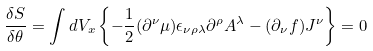Convert formula to latex. <formula><loc_0><loc_0><loc_500><loc_500>\frac { \delta S } { \delta \theta } = \int d V _ { x } \left \{ - \frac { 1 } { 2 } ( \partial ^ { \nu } \mu ) \epsilon _ { \nu \rho \lambda } \partial ^ { \rho } A ^ { \lambda } - ( \partial _ { \nu } f ) J ^ { \nu } \right \} = 0</formula> 